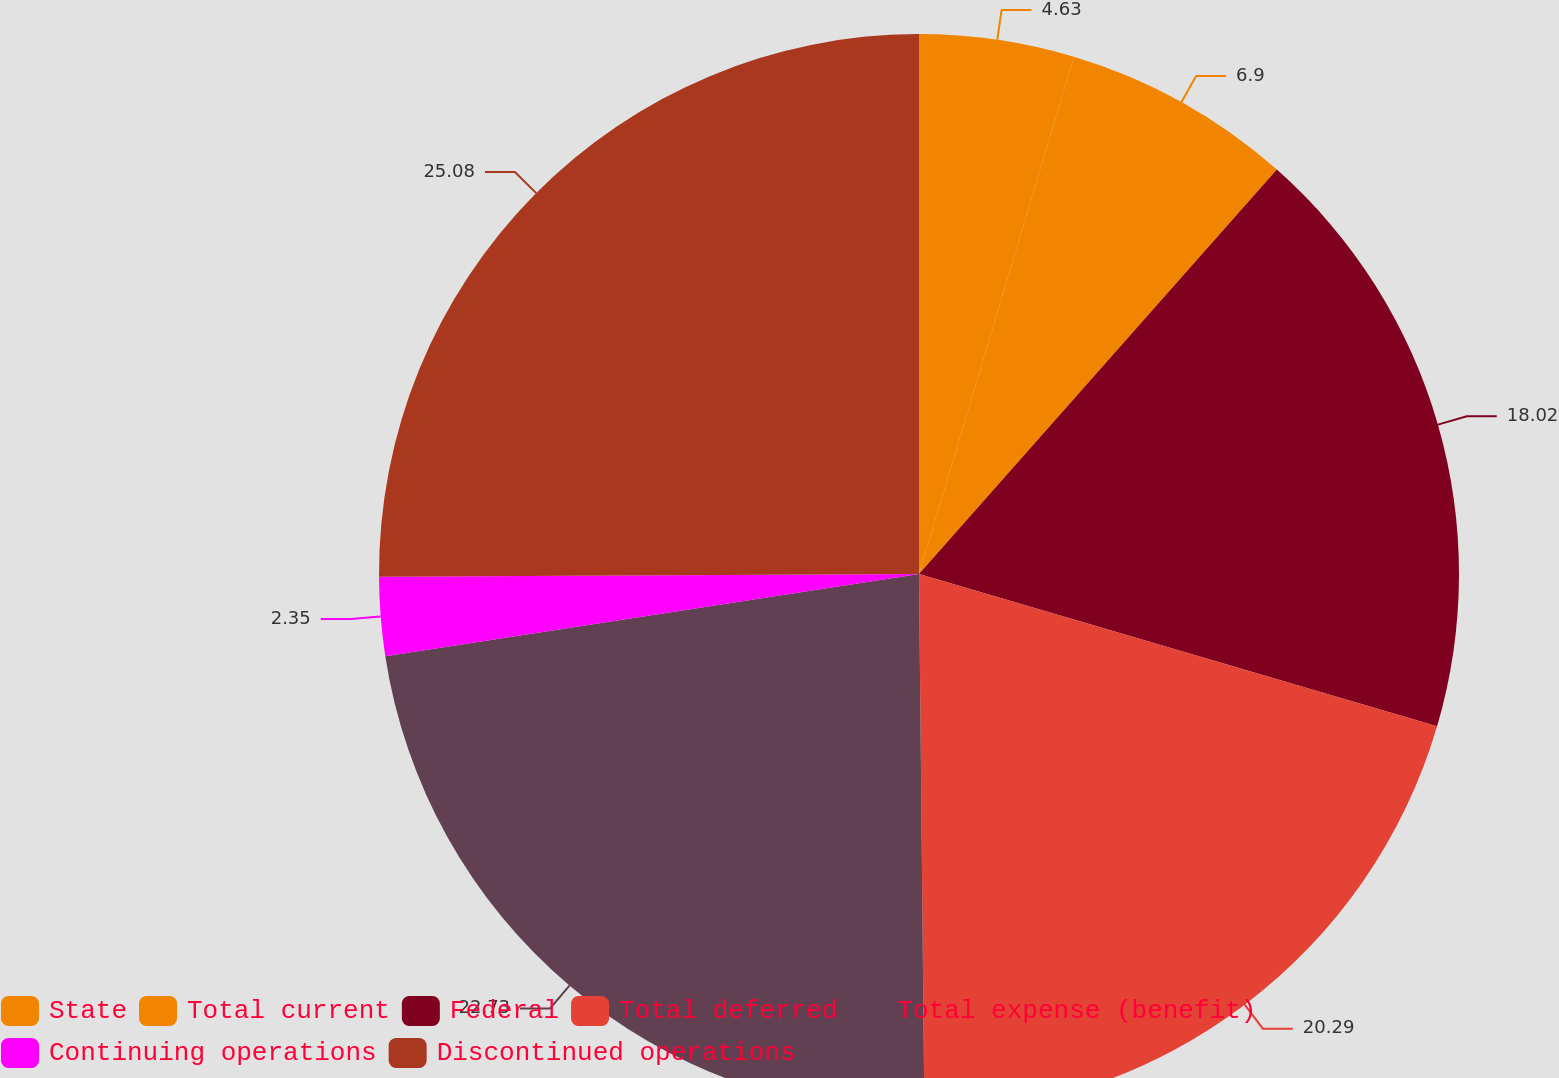Convert chart. <chart><loc_0><loc_0><loc_500><loc_500><pie_chart><fcel>State<fcel>Total current<fcel>Federal<fcel>Total deferred<fcel>Total expense (benefit)<fcel>Continuing operations<fcel>Discontinued operations<nl><fcel>4.63%<fcel>6.9%<fcel>18.02%<fcel>20.29%<fcel>22.73%<fcel>2.35%<fcel>25.08%<nl></chart> 